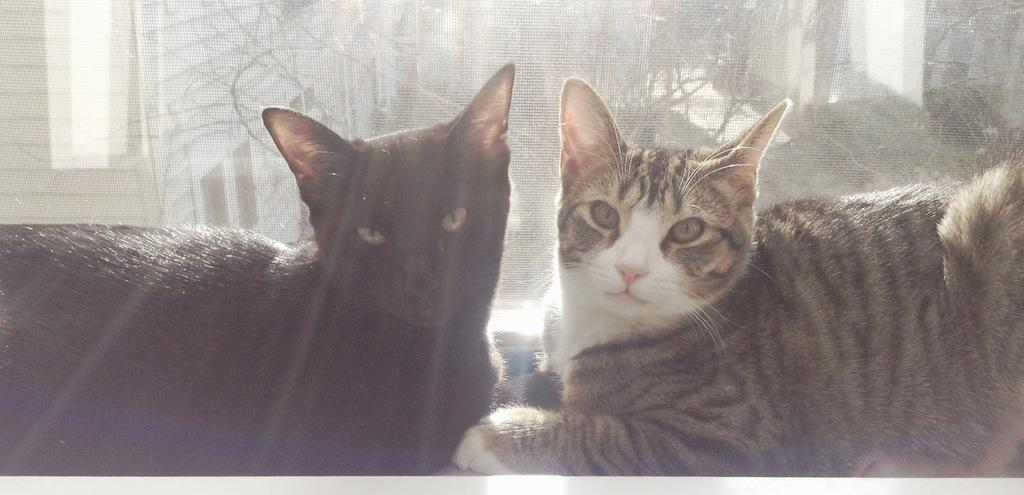How many cats are present in the image? There are two cats in the image. What can be seen on the window in the image? There is a curtain on the window in the image. What type of lumber is being used to build the cats' house in the image? There is no mention of a house or lumber in the image; it only features two cats and a curtain on a window. 